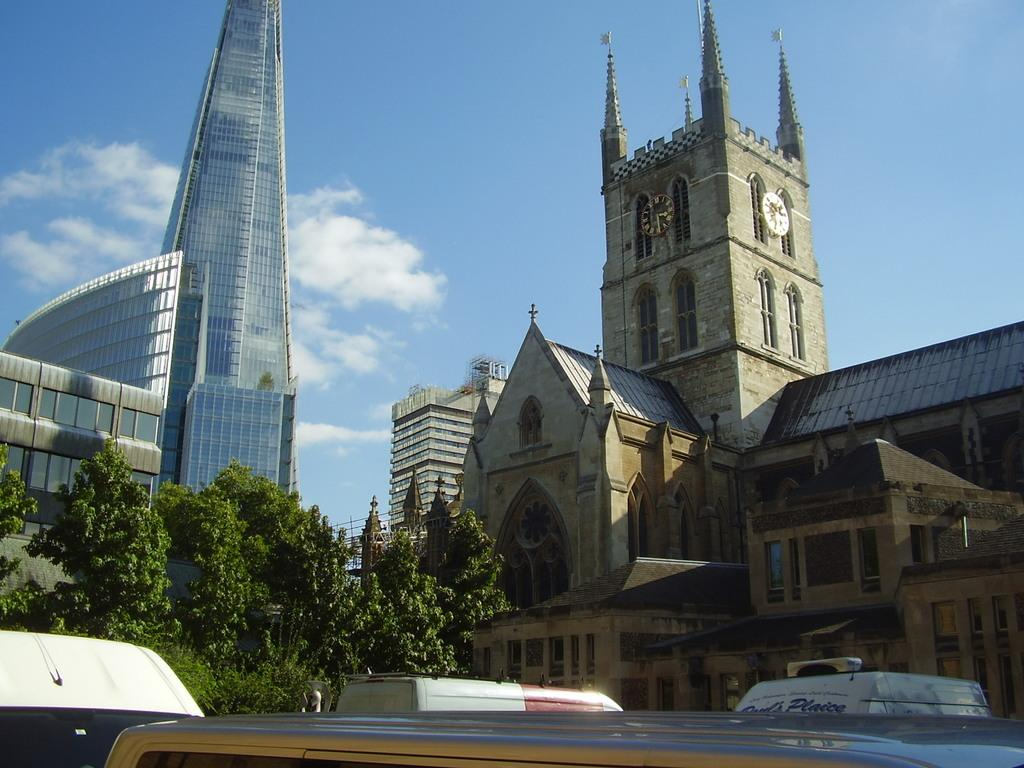What type of structures can be seen in the image? There are buildings in the image. What feature do the buildings have? The buildings have windows. What else is present in the image besides buildings? There are trees, vehicles, and two blocks attached to a wall in the image. What is the color of the sky in the image? The sky is blue and white in color. Where is the stove located in the image? There is no stove present in the image. What type of mailbox can be seen in the image? There is no mailbox present in the image. 